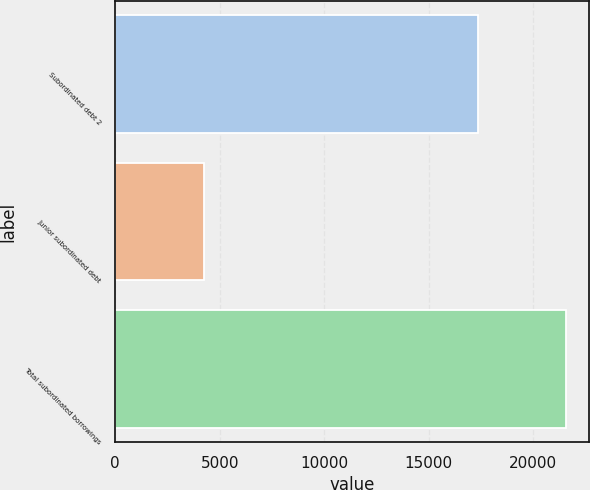Convert chart to OTSL. <chart><loc_0><loc_0><loc_500><loc_500><bar_chart><fcel>Subordinated debt 2<fcel>Junior subordinated debt<fcel>Total subordinated borrowings<nl><fcel>17358<fcel>4228<fcel>21586<nl></chart> 